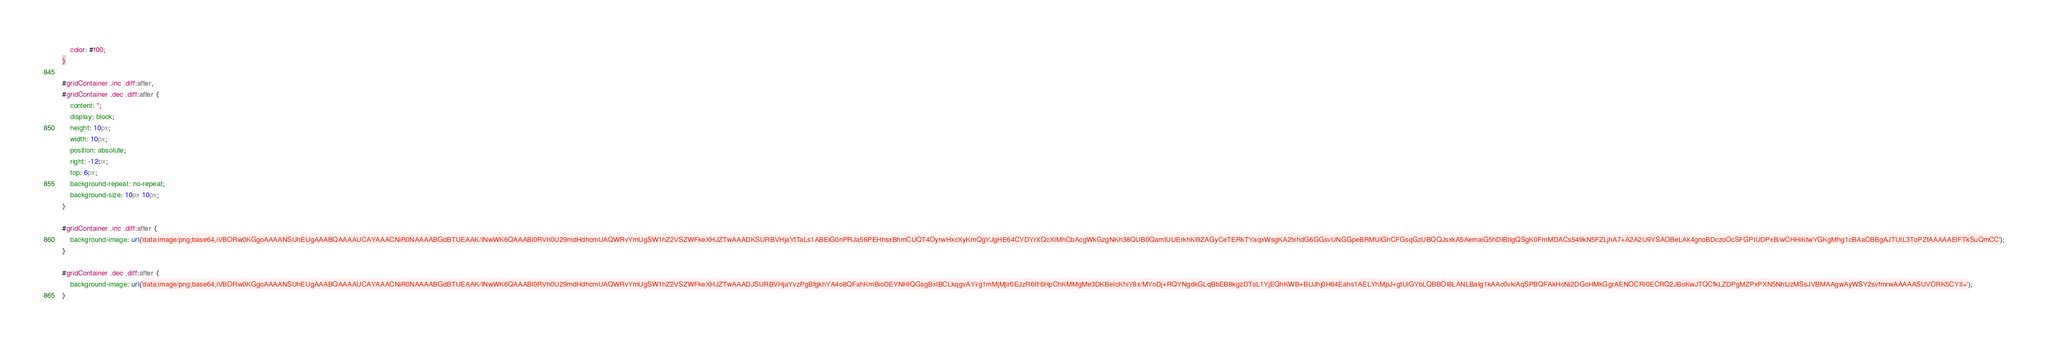Convert code to text. <code><loc_0><loc_0><loc_500><loc_500><_CSS_>    color: #f00;
}

#gridContainer .inc .diff:after,
#gridContainer .dec .diff:after {
    content: '';
    display: block;
    height: 10px;
    width: 10px;
    position: absolute;
    right: -12px;
    top: 6px;
    background-repeat: no-repeat;
    background-size: 10px 10px;
}

#gridContainer .inc .diff:after {
    background-image: url('data:image/png;base64,iVBORw0KGgoAAAANSUhEUgAAABQAAAAUCAYAAACNiR0NAAAABGdBTUEAAK/INwWK6QAAABl0RVh0U29mdHdhcmUAQWRvYmUgSW1hZ2VSZWFkeXHJZTwAAADKSURBVHjaYtTaLs1ABEiG0nPRJa56PEHhsxBhmCUQT4OyrwHxcXyKmQgYJgHE64CYDYrXQcXIMhCbAcgWkGzgNKh38QUB0QamIUUErkhKI9ZAGyCeTERkTYaqxWsgKA2txhdG6GGsvUNGGpeBRMUiGhCFGsqGzUBQQJsxkA5AemaiG5hDIBIIgQSgK0FmMDACs549kN5FZLjhA7+A2A2U9YSAOBeLAk4gnoBDczoOcSFGPIUDPxB/wCHHiKtwYGKgMhg1cBAaCBBgAJTUIL3ToPZfAAAAAElFTkSuQmCC');
}

#gridContainer .dec .diff:after {
    background-image: url('data:image/png;base64,iVBORw0KGgoAAAANSUhEUgAAABQAAAAUCAYAAACNiR0NAAAABGdBTUEAAK/INwWK6QAAABl0RVh0U29mdHdhcmUAQWRvYmUgSW1hZ2VSZWFkeXHJZTwAAADJSURBVHjaYvzPgBfgkhYA4o8QFahKmBioDEYNHIQGsgBxIBCLkqgvAYi/g1mMjMjir0EJzR6If/6HpChKMMgMe3DKBeIcKhiY8x/MYoDj+RQYNgdkGLqBbEB8kgzDToL1YjEQhKWB+BUJhj0H64Eahs1AELYhMpJ+gtUiGYbLQBBOI8LANLBaIg1kAAc0vkiAqSPBQFAkHcNi2DGoHMkGgrAENOCRI0ECRQ2JBoKwJTQCfkLZDPgMZPxPXN5NhtJzMSsJVBMAAgwAyWSY2svfmrwAAAAASUVORK5CYII=');    
}</code> 